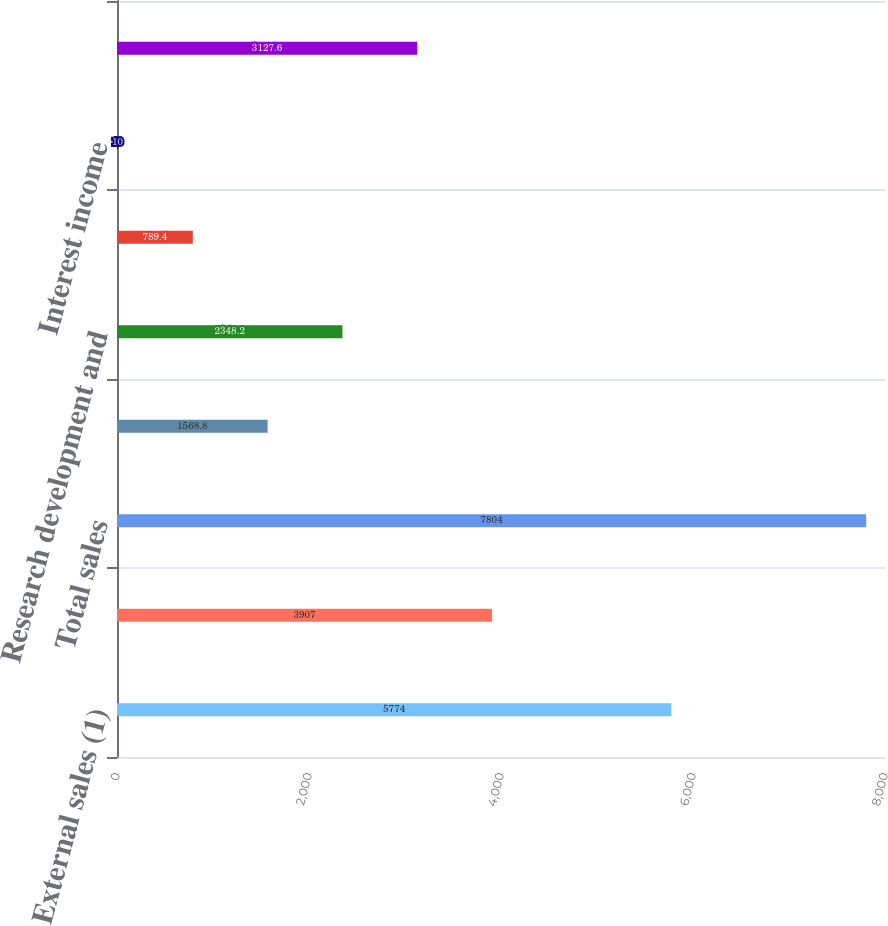Convert chart to OTSL. <chart><loc_0><loc_0><loc_500><loc_500><bar_chart><fcel>External sales (1)<fcel>Intersegment sales (1)<fcel>Total sales<fcel>Depreciation and amortization<fcel>Research development and<fcel>Equity royalty and interest<fcel>Interest income<fcel>Segment EBIT<nl><fcel>5774<fcel>3907<fcel>7804<fcel>1568.8<fcel>2348.2<fcel>789.4<fcel>10<fcel>3127.6<nl></chart> 